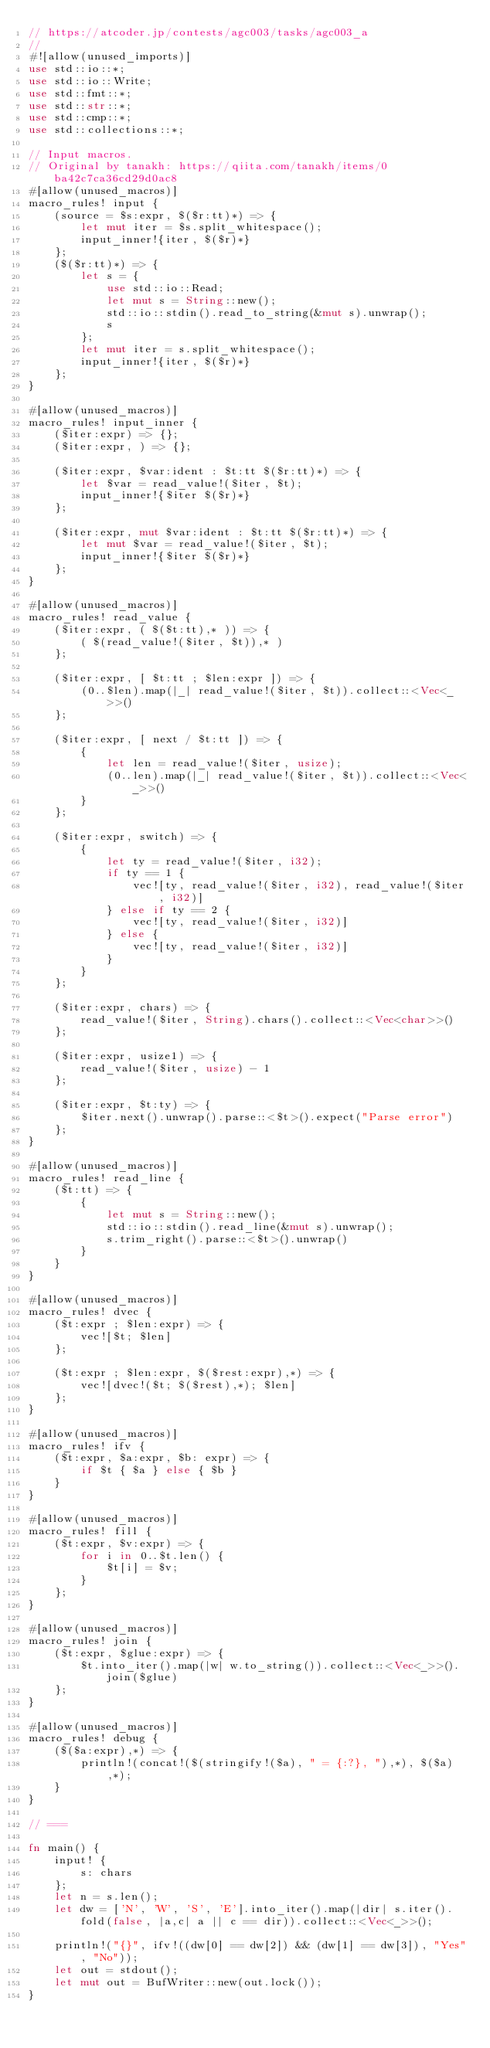Convert code to text. <code><loc_0><loc_0><loc_500><loc_500><_Rust_>// https://atcoder.jp/contests/agc003/tasks/agc003_a
//
#![allow(unused_imports)]
use std::io::*;
use std::io::Write;
use std::fmt::*;
use std::str::*;
use std::cmp::*;
use std::collections::*;

// Input macros.
// Original by tanakh: https://qiita.com/tanakh/items/0ba42c7ca36cd29d0ac8
#[allow(unused_macros)]
macro_rules! input {
    (source = $s:expr, $($r:tt)*) => {
        let mut iter = $s.split_whitespace();
        input_inner!{iter, $($r)*}
    };
    ($($r:tt)*) => {
        let s = {
            use std::io::Read;
            let mut s = String::new();
            std::io::stdin().read_to_string(&mut s).unwrap();
            s
        };
        let mut iter = s.split_whitespace();
        input_inner!{iter, $($r)*}
    };
}

#[allow(unused_macros)]
macro_rules! input_inner {
    ($iter:expr) => {};
    ($iter:expr, ) => {};

    ($iter:expr, $var:ident : $t:tt $($r:tt)*) => {
        let $var = read_value!($iter, $t);
        input_inner!{$iter $($r)*}
    };

    ($iter:expr, mut $var:ident : $t:tt $($r:tt)*) => {
        let mut $var = read_value!($iter, $t);
        input_inner!{$iter $($r)*}
    };
}

#[allow(unused_macros)]
macro_rules! read_value {
    ($iter:expr, ( $($t:tt),* )) => {
        ( $(read_value!($iter, $t)),* )
    };

    ($iter:expr, [ $t:tt ; $len:expr ]) => {
        (0..$len).map(|_| read_value!($iter, $t)).collect::<Vec<_>>()
    };

    ($iter:expr, [ next / $t:tt ]) => {
        {
            let len = read_value!($iter, usize);
            (0..len).map(|_| read_value!($iter, $t)).collect::<Vec<_>>()
        }
    };

    ($iter:expr, switch) => {
        {
            let ty = read_value!($iter, i32);
            if ty == 1 {
                vec![ty, read_value!($iter, i32), read_value!($iter, i32)]
            } else if ty == 2 {
                vec![ty, read_value!($iter, i32)]
            } else {
                vec![ty, read_value!($iter, i32)]
            }
        }
    };

    ($iter:expr, chars) => {
        read_value!($iter, String).chars().collect::<Vec<char>>()
    };

    ($iter:expr, usize1) => {
        read_value!($iter, usize) - 1
    };

    ($iter:expr, $t:ty) => {
        $iter.next().unwrap().parse::<$t>().expect("Parse error")
    };
}

#[allow(unused_macros)]
macro_rules! read_line {
    ($t:tt) => {
        {
            let mut s = String::new();
            std::io::stdin().read_line(&mut s).unwrap();
            s.trim_right().parse::<$t>().unwrap()
        }
    }
}

#[allow(unused_macros)]
macro_rules! dvec {
    ($t:expr ; $len:expr) => {
        vec![$t; $len]
    };

    ($t:expr ; $len:expr, $($rest:expr),*) => {
        vec![dvec!($t; $($rest),*); $len]
    };
}

#[allow(unused_macros)]
macro_rules! ifv {
    ($t:expr, $a:expr, $b: expr) => {
        if $t { $a } else { $b }
    }
}

#[allow(unused_macros)]
macro_rules! fill {
    ($t:expr, $v:expr) => {
        for i in 0..$t.len() {
            $t[i] = $v;
        }
    };
}

#[allow(unused_macros)]
macro_rules! join {
    ($t:expr, $glue:expr) => {
        $t.into_iter().map(|w| w.to_string()).collect::<Vec<_>>().join($glue)
    };
}

#[allow(unused_macros)]
macro_rules! debug {
    ($($a:expr),*) => {
        println!(concat!($(stringify!($a), " = {:?}, "),*), $($a),*);
    }
}

// ===

fn main() {
    input! {
        s: chars
    };
    let n = s.len();
    let dw = ['N', 'W', 'S', 'E'].into_iter().map(|dir| s.iter().fold(false, |a,c| a || c == dir)).collect::<Vec<_>>();

    println!("{}", ifv!((dw[0] == dw[2]) && (dw[1] == dw[3]), "Yes", "No"));
    let out = stdout();
    let mut out = BufWriter::new(out.lock());
}
</code> 